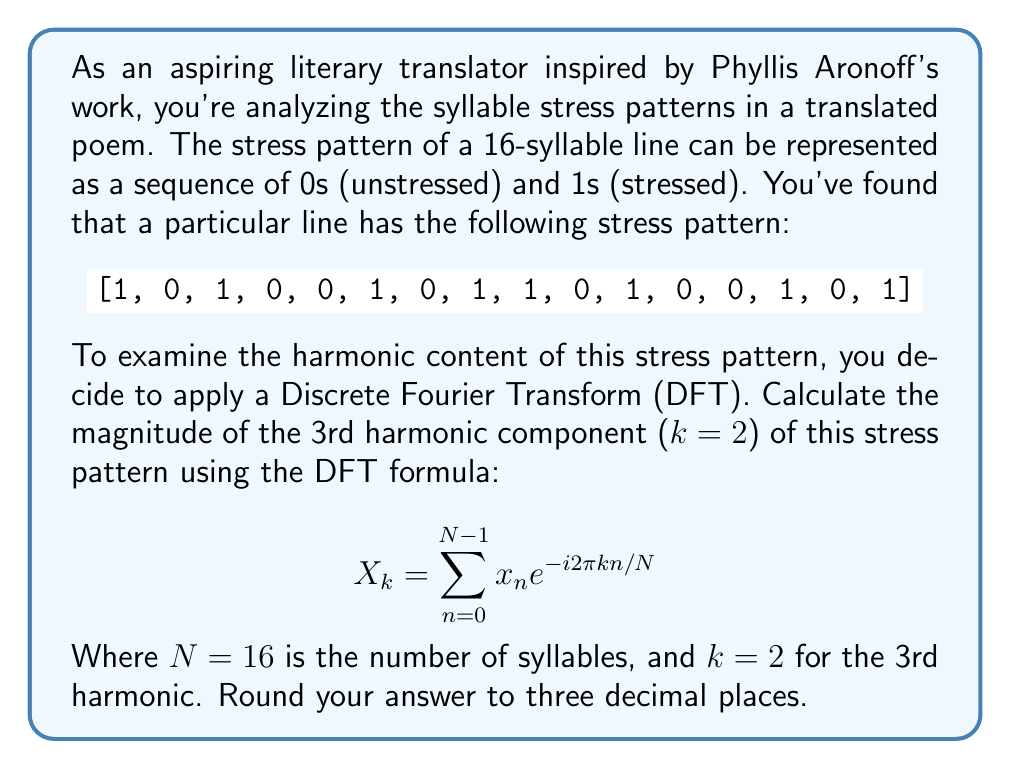Show me your answer to this math problem. To solve this problem, we'll follow these steps:

1) The DFT formula for the 3rd harmonic (k=2) is:

   $$X_2 = \sum_{n=0}^{15} x_n e^{-i2\pi (2)n/16}$$

2) Expand this sum:

   $$X_2 = x_0 e^{-i2\pi (2)(0)/16} + x_1 e^{-i2\pi (2)(1)/16} + ... + x_{15} e^{-i2\pi (2)(15)/16}$$

3) Simplify the exponents:

   $$X_2 = x_0 e^{0} + x_1 e^{-i\pi/4} + x_2 e^{-i\pi/2} + x_3 e^{-i3\pi/4} + x_4 e^{-i\pi} + ... + x_{15} e^{-i15\pi/4}$$

4) Substitute the values of $x_n$ from the given stress pattern:

   $$X_2 = 1 + 0\cdot e^{-i\pi/4} + 1\cdot e^{-i\pi/2} + 0\cdot e^{-i3\pi/4} + 0\cdot e^{-i\pi} + 1\cdot e^{-i5\pi/4} + ...$$

5) Evaluate this sum. The non-zero terms are:

   $$X_2 = 1 + e^{-i\pi/2} + e^{-i5\pi/4} + e^{-i7\pi/4} + e^{-i2\pi} + e^{-i9\pi/4} + e^{-i11\pi/4} + e^{-i15\pi/4}$$

6) Simplify:

   $$X_2 = 1 - i - (0.707 + 0.707i) + (0.707 - 0.707i) + 1 + (0.707 + 0.707i) - (0.707 - 0.707i) - (0.707 + 0.707i)$$

7) Combine like terms:

   $$X_2 = 2 - 0.707i$$

8) Calculate the magnitude:

   $$|X_2| = \sqrt{2^2 + (-0.707)^2} = \sqrt{4 + 0.5} = \sqrt{4.5} \approx 2.121$$

9) Round to three decimal places: 2.121
Answer: 2.121 